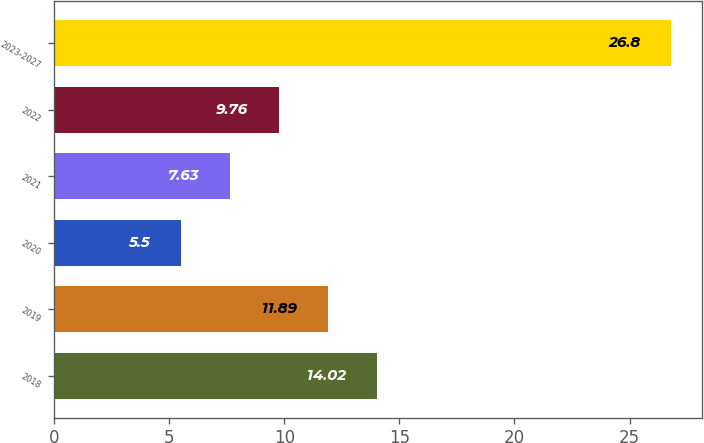Convert chart to OTSL. <chart><loc_0><loc_0><loc_500><loc_500><bar_chart><fcel>2018<fcel>2019<fcel>2020<fcel>2021<fcel>2022<fcel>2023-2027<nl><fcel>14.02<fcel>11.89<fcel>5.5<fcel>7.63<fcel>9.76<fcel>26.8<nl></chart> 